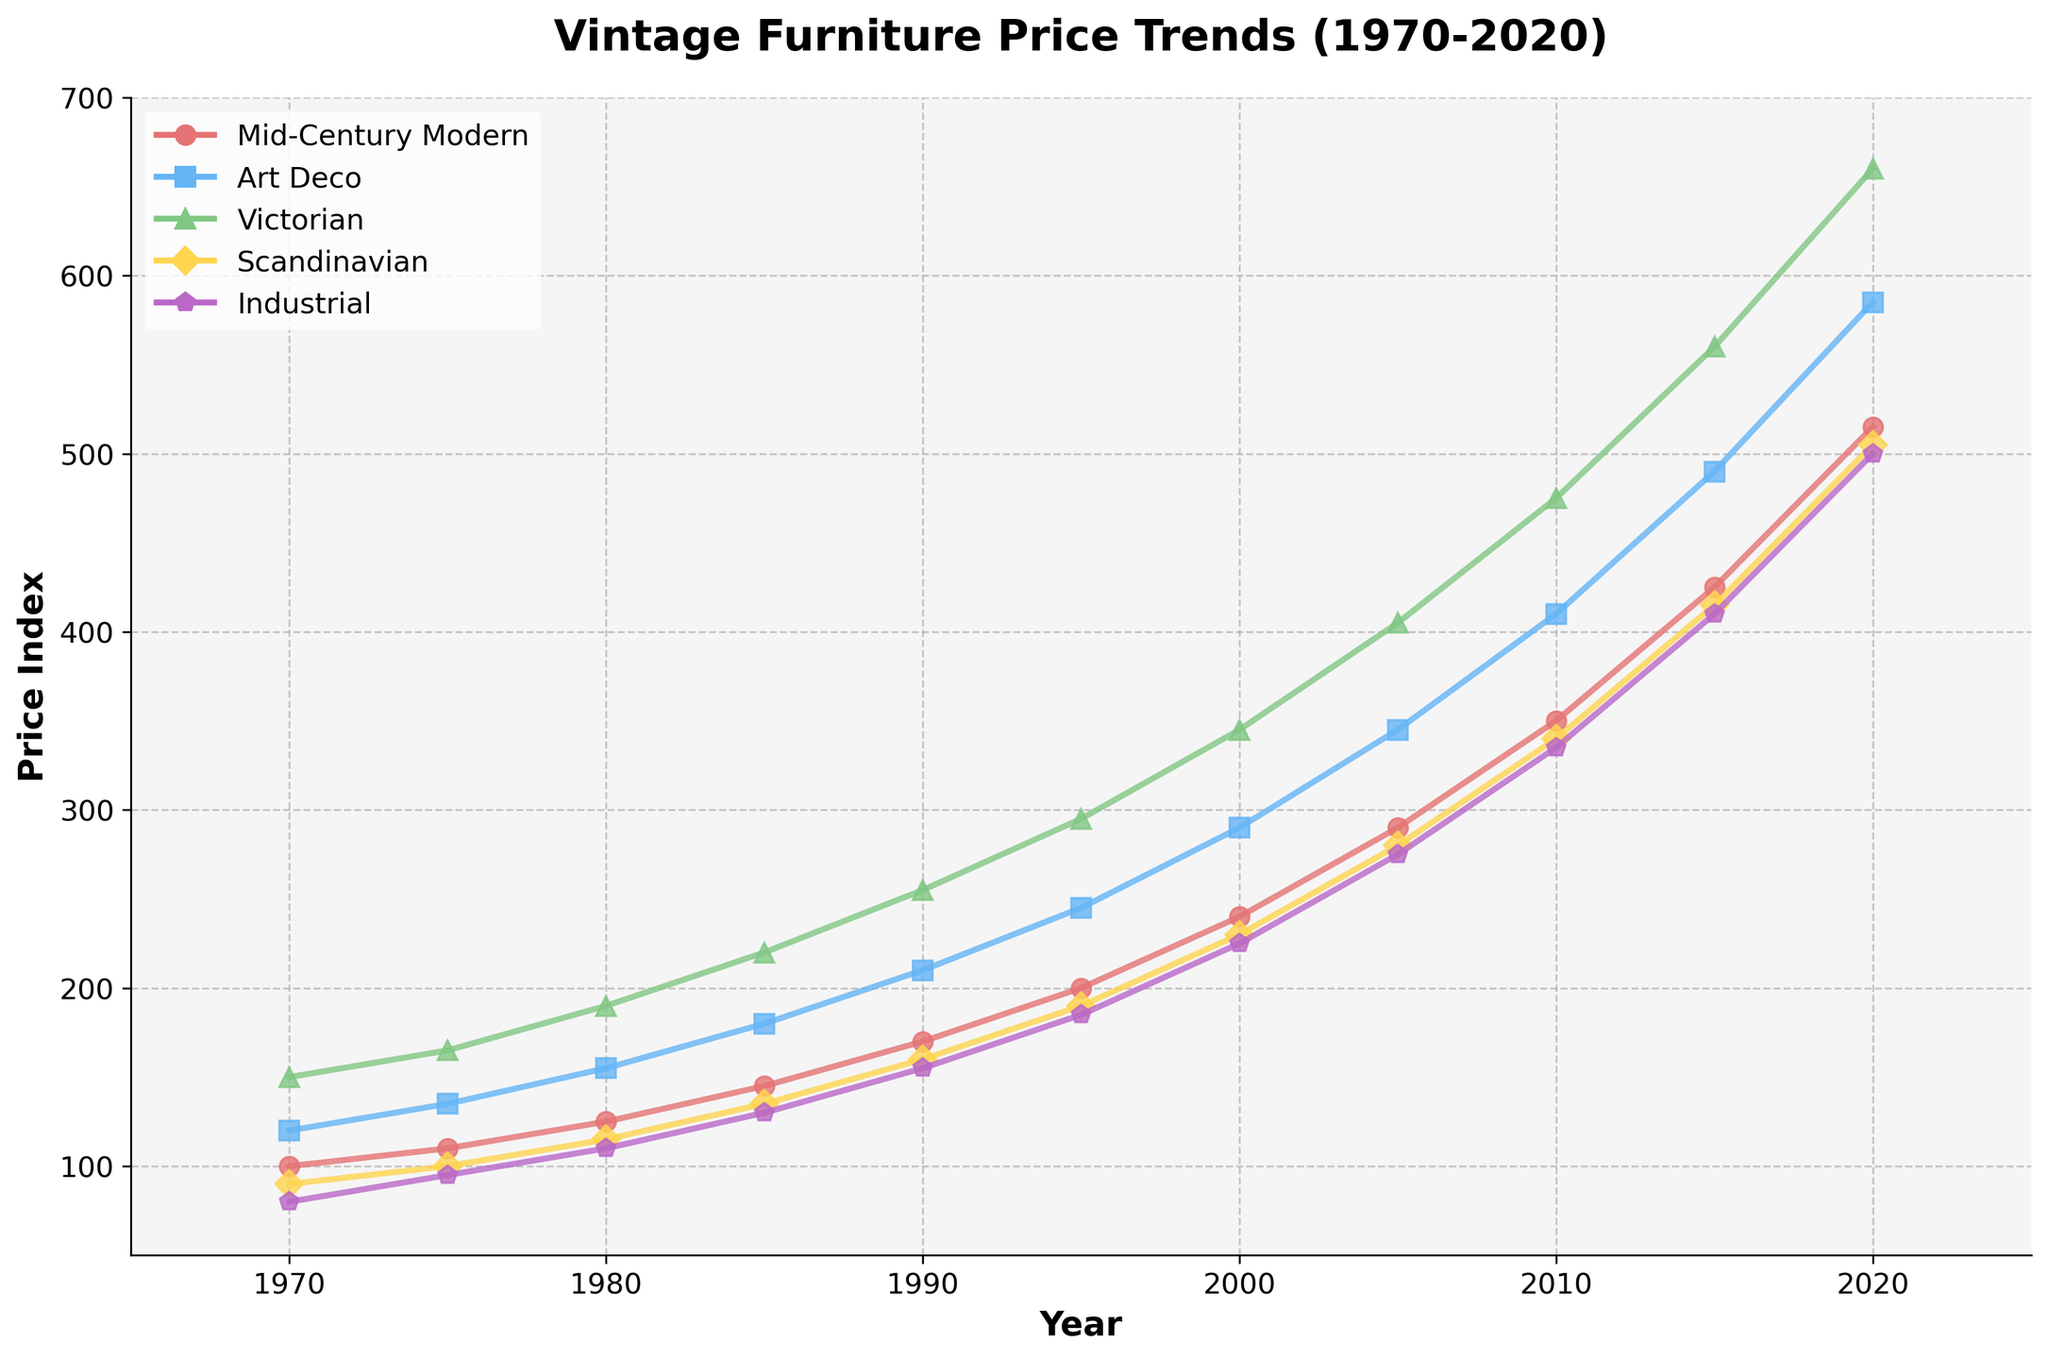Which style had the fastest growth in prices from 1970 to 2020? To determine the fastest growth, calculate the difference in prices between 2020 and 1970 for each style. Mid-Century Modern: 515 - 100 = 415, Art Deco: 585 - 120 = 465, Victorian: 660 - 150 = 510, Scandinavian: 505 - 90 = 415, Industrial: 500 - 80 = 420. Since Victorian has the highest difference at 510, it had the fastest growth.
Answer: Victorian Which style was consistently the most expensive from 1970 to 2020? We look at the price values for each style in every year and identify the style with the highest price in nearly all the years. From the data, Victorian consistently has the highest prices across all years.
Answer: Victorian What's the average price of Scandinavian furniture from 1970 to 2020? Average is calculated by summing up all the prices and dividing by the total number of data points. (90 + 100 + 115 + 135 + 160 + 190 + 230 + 280 + 340 + 415 + 505) / 11 = 2560 / 11 ≈ 232.73
Answer: 232.73 Which style saw the largest price decrease in any single year? We need to look at year-to-year changes and find the largest negative difference. However, since all prices steadily increase over the years, there were no price decreases for any style. As per the given data, there was no price decrease.
Answer: No price decrease How many years did it take for Mid-Century Modern prices to double from their 1970 value? The 1970 price of Mid-Century Modern is 100. Doubling that means reaching 200. From the data, this occurs in 1995. Thus, 1995 - 1970 = 25 years.
Answer: 25 years Which style had the smallest price increase between 2015 and 2020? Calculate the increase for each style: Mid-Century Modern: 515 - 425 = 90, Art Deco: 585 - 490 = 95, Victorian: 660 - 560 = 100, Scandinavian: 505 - 415 = 90, Industrial: 500 - 410 = 90. Mid-Century Modern, Scandinavian, and Industrial all had the smallest increase of 90.
Answer: Mid-Century Modern, Scandinavian, Industrial What was the price of Industrial furniture in 2005 and how does it compare to its price in 2010? From the data, the price in 2005 was 275 and in 2010 it was 335. The comparison shows an increase of 335 - 275 = 60.
Answer: Increased by 60 What is the total price increase of Victorian furniture from 1980 to 2010? Calculate the difference between the 1980 and 2010 prices: 475 - 190 = 285
Answer: 285 In which year did Art Deco furniture prices surpass Victorian furniture prices? We compare each year's prices for Art Deco and Victorian. By inspecting the data, at no point between 1970 and 2020 does Art Deco surpass Victorian. Therefore, the answer is it did not happen within the given range.
Answer: Did not happen How do Scandinavian furniture prices in 1990 compare to Mid-Century Modern prices in the same year? From the data, Scandinavian price in 1990 is 160 and Mid-Century Modern is 170. Scandinavian is less expensive than Mid-Century Modern in 1990.
Answer: Less expensive 